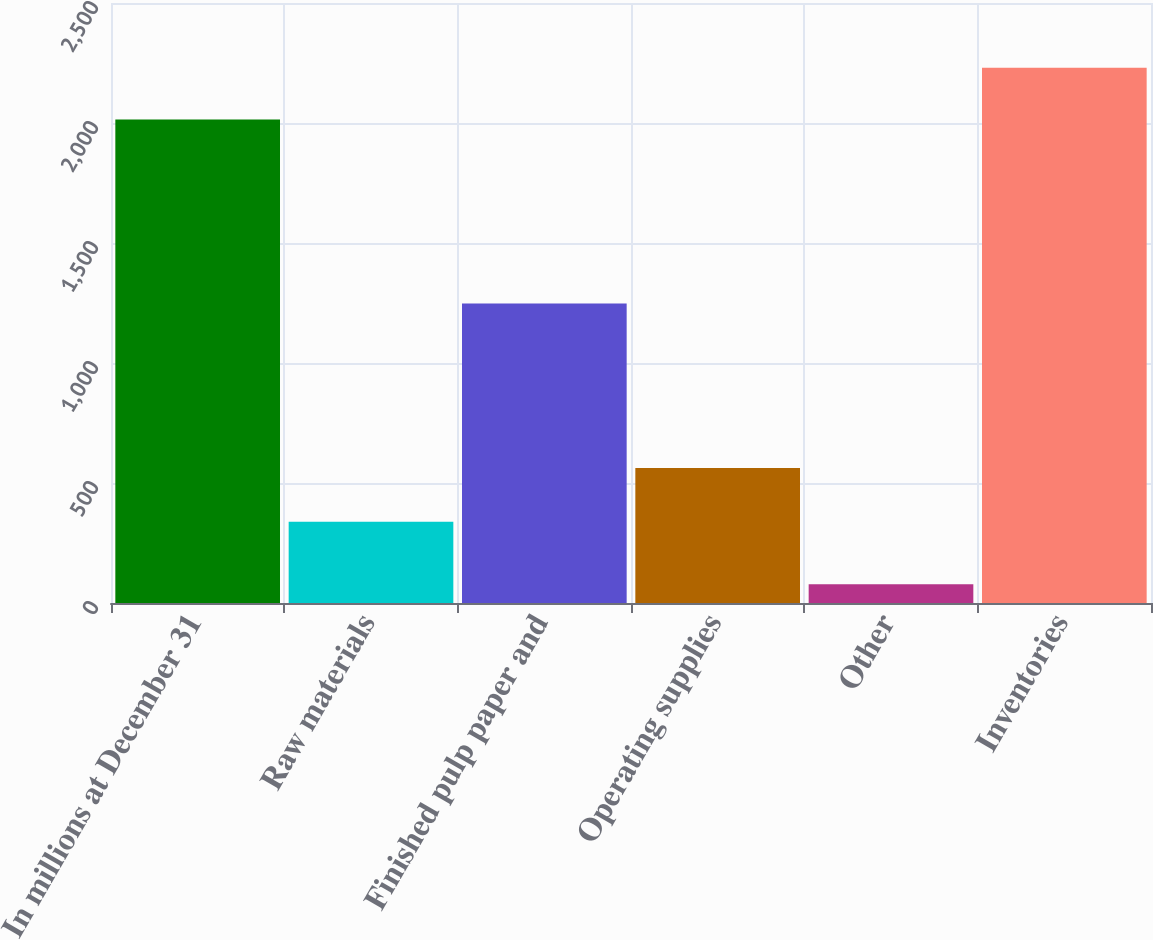<chart> <loc_0><loc_0><loc_500><loc_500><bar_chart><fcel>In millions at December 31<fcel>Raw materials<fcel>Finished pulp paper and<fcel>Operating supplies<fcel>Other<fcel>Inventories<nl><fcel>2015<fcel>339<fcel>1248<fcel>563<fcel>78<fcel>2230<nl></chart> 